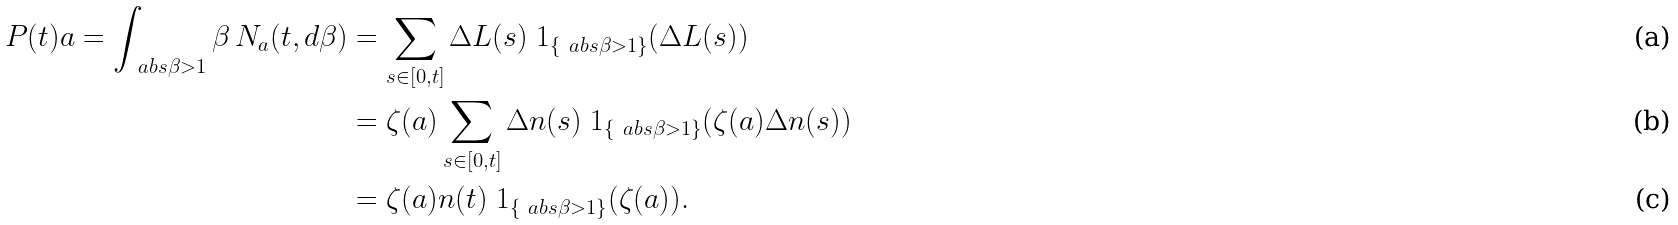Convert formula to latex. <formula><loc_0><loc_0><loc_500><loc_500>P ( t ) a = \int _ { \ a b s { \beta } > 1 } \beta \, N _ { a } ( t , d \beta ) & = \sum _ { s \in [ 0 , t ] } \Delta L ( s ) \ 1 _ { \{ \ a b s { \beta } > 1 \} } ( \Delta L ( s ) ) \\ & = \zeta ( a ) \sum _ { s \in [ 0 , t ] } \Delta n ( s ) \ 1 _ { \{ \ a b s { \beta } > 1 \} } ( \zeta ( a ) \Delta n ( s ) ) \\ & = \zeta ( a ) n ( t ) \ 1 _ { \{ \ a b s { \beta } > 1 \} } ( \zeta ( a ) ) .</formula> 